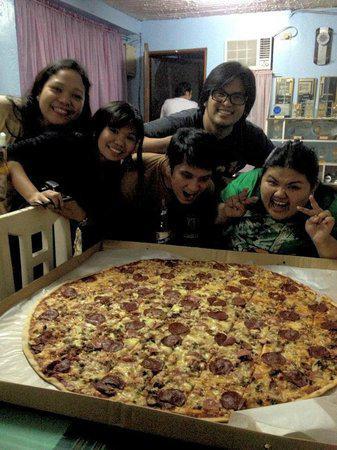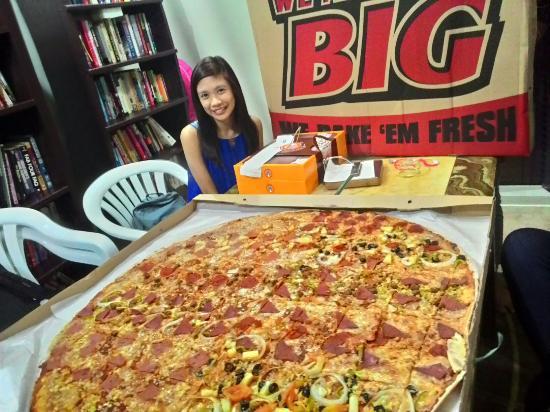The first image is the image on the left, the second image is the image on the right. Evaluate the accuracy of this statement regarding the images: "The left image features a round pizza on a round metal tray, and the right image features a large round pizza in an open cardboard box with a person on the right of it.". Is it true? Answer yes or no. No. The first image is the image on the left, the second image is the image on the right. Evaluate the accuracy of this statement regarding the images: "There are two whole pizzas.". Is it true? Answer yes or no. Yes. 